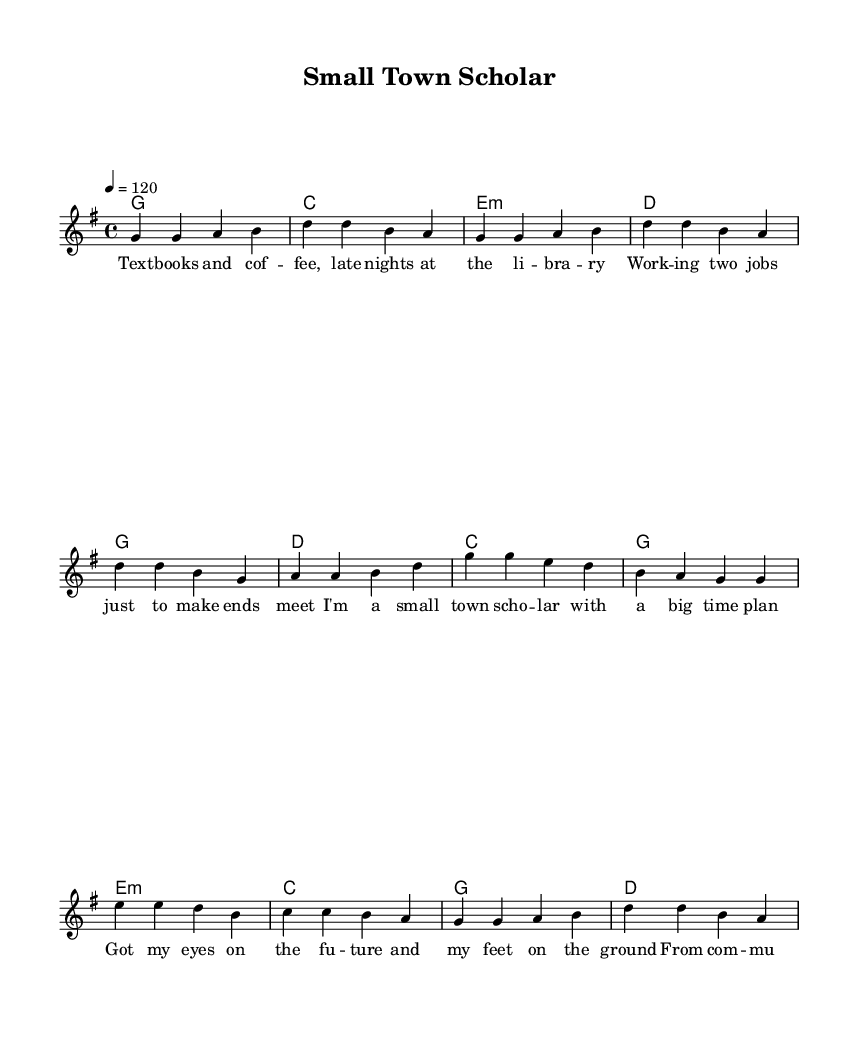What is the key signature of this music? The key signature is G major, which has one sharp (F#). This can be confirmed by looking at the key signature indicated at the beginning of the score.
Answer: G major What is the time signature of this music? The time signature is 4/4, which means there are four beats in each measure and the quarter note gets one beat. This information is also at the beginning of the score, directly following the key signature.
Answer: 4/4 What is the tempo marking in this music? The tempo marking is quarter note equals 120, indicating the speed of the piece. It guides performers on how fast to play the music and is found within the "global" section at the beginning.
Answer: 120 How many measures are in the verse section? The verse section consists of 8 measures. This can be determined by counting the measure bars in the "melody" section labeled as the verse.
Answer: 8 What is the primary theme of the lyrics in the chorus? The primary theme of the lyrics in the chorus revolves around academic aspirations and optimism for the future. By reading the lyrics, one can identify this central message about being a small-town scholar with ambitions.
Answer: Academic ambitions How does the bridge contribute to the overall song structure? The bridge provides a contrasting section that highlights the journey from community college to prestigious universities, emphasizing personal growth and future possibilities. This is typical in Country Rock to showcase change and maturation.
Answer: Personal growth What style characteristics can you identify that classify this music as Country Rock? The song contains thematic elements of personal storytelling, a strong backbeat, and a blend of rock instrumentation with country melodies, which are defining features of Country Rock music. Listening closely reveals this unique combination.
Answer: Storytelling and instrumentation 